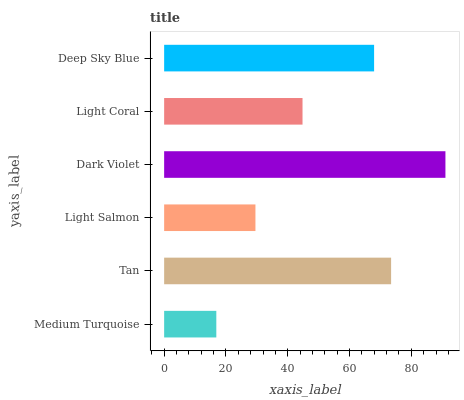Is Medium Turquoise the minimum?
Answer yes or no. Yes. Is Dark Violet the maximum?
Answer yes or no. Yes. Is Tan the minimum?
Answer yes or no. No. Is Tan the maximum?
Answer yes or no. No. Is Tan greater than Medium Turquoise?
Answer yes or no. Yes. Is Medium Turquoise less than Tan?
Answer yes or no. Yes. Is Medium Turquoise greater than Tan?
Answer yes or no. No. Is Tan less than Medium Turquoise?
Answer yes or no. No. Is Deep Sky Blue the high median?
Answer yes or no. Yes. Is Light Coral the low median?
Answer yes or no. Yes. Is Tan the high median?
Answer yes or no. No. Is Medium Turquoise the low median?
Answer yes or no. No. 